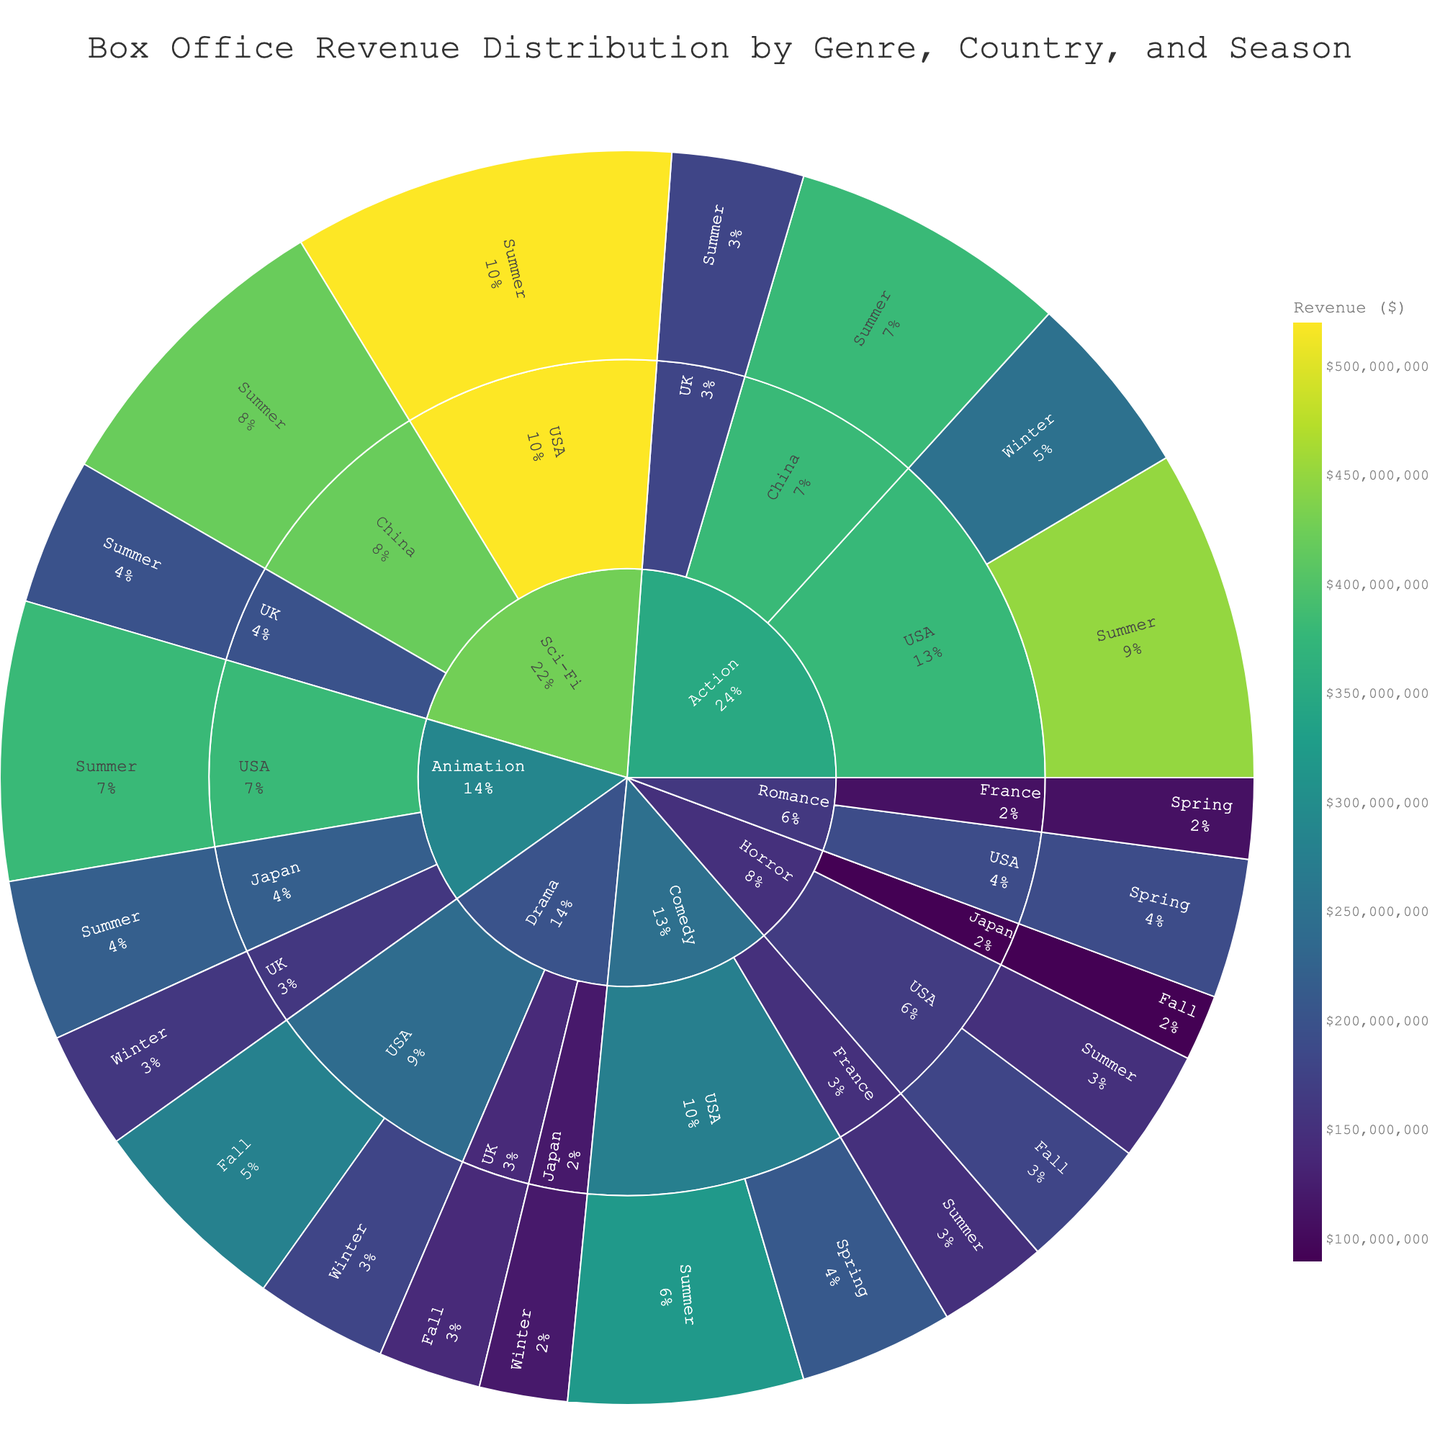How many genres are represented in the sunburst plot? The sunburst plot categorizes the data first by genre, then by country, and finally by season. Counting the highest hierarchical labels gives the number of genres.
Answer: 7 Which country has the highest overall box office revenue for the Action genre? For the Action genre, identify the countries represented (USA, China, UK) and compare their total revenues (450,000,000 for USA, 380,000,000 for China, 180,000,000 for UK).
Answer: USA What is the combined revenue from Sci-Fi movies released in the Summer in both the USA and China? Add the revenue from Sci-Fi movies released in the summer in the USA (520,000,000) and China (420,000,000).
Answer: 940,000,000 How does Winter revenue for Drama in Japan compare to Winter revenue for Animation in the UK? Compare the revenues directly: Drama in Japan (120,000,000) vs. Animation in the UK (160,000,000).
Answer: Animation in the UK has higher revenue Which season generates the highest revenue for Comedy movies in the USA? Compare the revenues from Comedy movies in the USA for different seasons: Summer (320,000,000) and Spring (210,000,000).
Answer: Summer How much more revenue does the USA generate with Horror movies in Fall compared to Summer? Calculate the difference between Fall and Summer revenues for Horror movies in the USA: 180,000,000 (Fall) - 150,000,000 (Summer).
Answer: 30,000,000 Which genre produced the highest single-season revenue across all categories? Identify the highest revenue in a single season by comparing all categorized revenues. Sci-Fi in the USA during Summer has the highest revenue of 520,000,000.
Answer: Sci-Fi What is the total revenue from Romance movies in both the USA and France during Spring? Sum the revenues from Romance movies in the USA (190,000,000) and France (110,000,000) during Spring.
Answer: 300,000,000 Between Action movies in China and Sci-Fi movies in the UK, which has higher Summer revenue? Compare the revenues: Action in China (380,000,000) versus Sci-Fi in the UK (200,000,000).
Answer: Action in China What is the percentage contribution of Japanese Animation movies in Summer to the total Animation revenue? Japanese Animation revenue in Summer is 220,000,000. Total Animation revenue is the sum of USA (380,000,000), Japan (220,000,000), and UK (160,000,000), which equals 760,000,000. Calculate (220,000,000/760,000,000) * 100 to find the percentage.
Answer: 28.95% 